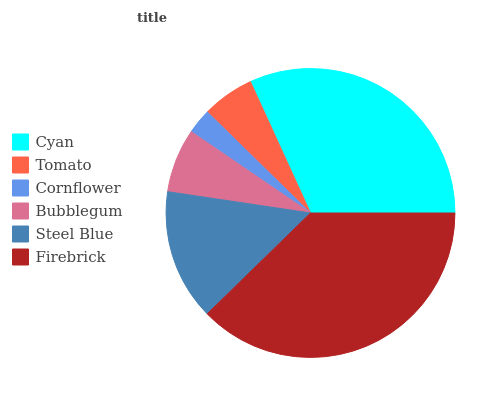Is Cornflower the minimum?
Answer yes or no. Yes. Is Firebrick the maximum?
Answer yes or no. Yes. Is Tomato the minimum?
Answer yes or no. No. Is Tomato the maximum?
Answer yes or no. No. Is Cyan greater than Tomato?
Answer yes or no. Yes. Is Tomato less than Cyan?
Answer yes or no. Yes. Is Tomato greater than Cyan?
Answer yes or no. No. Is Cyan less than Tomato?
Answer yes or no. No. Is Steel Blue the high median?
Answer yes or no. Yes. Is Bubblegum the low median?
Answer yes or no. Yes. Is Firebrick the high median?
Answer yes or no. No. Is Tomato the low median?
Answer yes or no. No. 